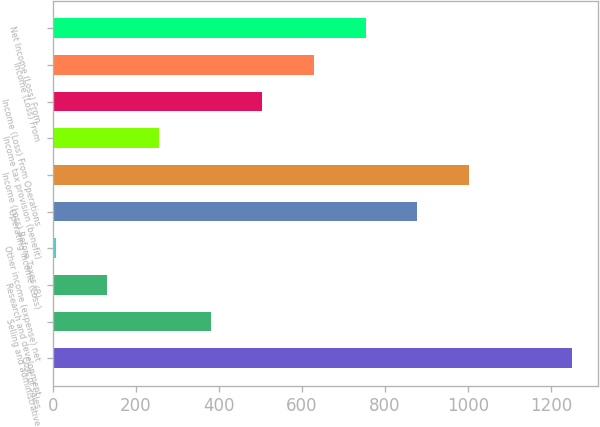Convert chart to OTSL. <chart><loc_0><loc_0><loc_500><loc_500><bar_chart><fcel>Cost of sales<fcel>Selling and administrative<fcel>Research and development<fcel>Other income (expense) net<fcel>Operating Income (Loss)<fcel>Income (Loss) Before Taxes (B)<fcel>Income tax provision (benefit)<fcel>Income (Loss) From Operations<fcel>Income (Loss) From<fcel>Net Income (Loss) From<nl><fcel>1250.7<fcel>379.62<fcel>130.74<fcel>6.3<fcel>877.38<fcel>1001.82<fcel>255.18<fcel>504.06<fcel>628.5<fcel>752.94<nl></chart> 